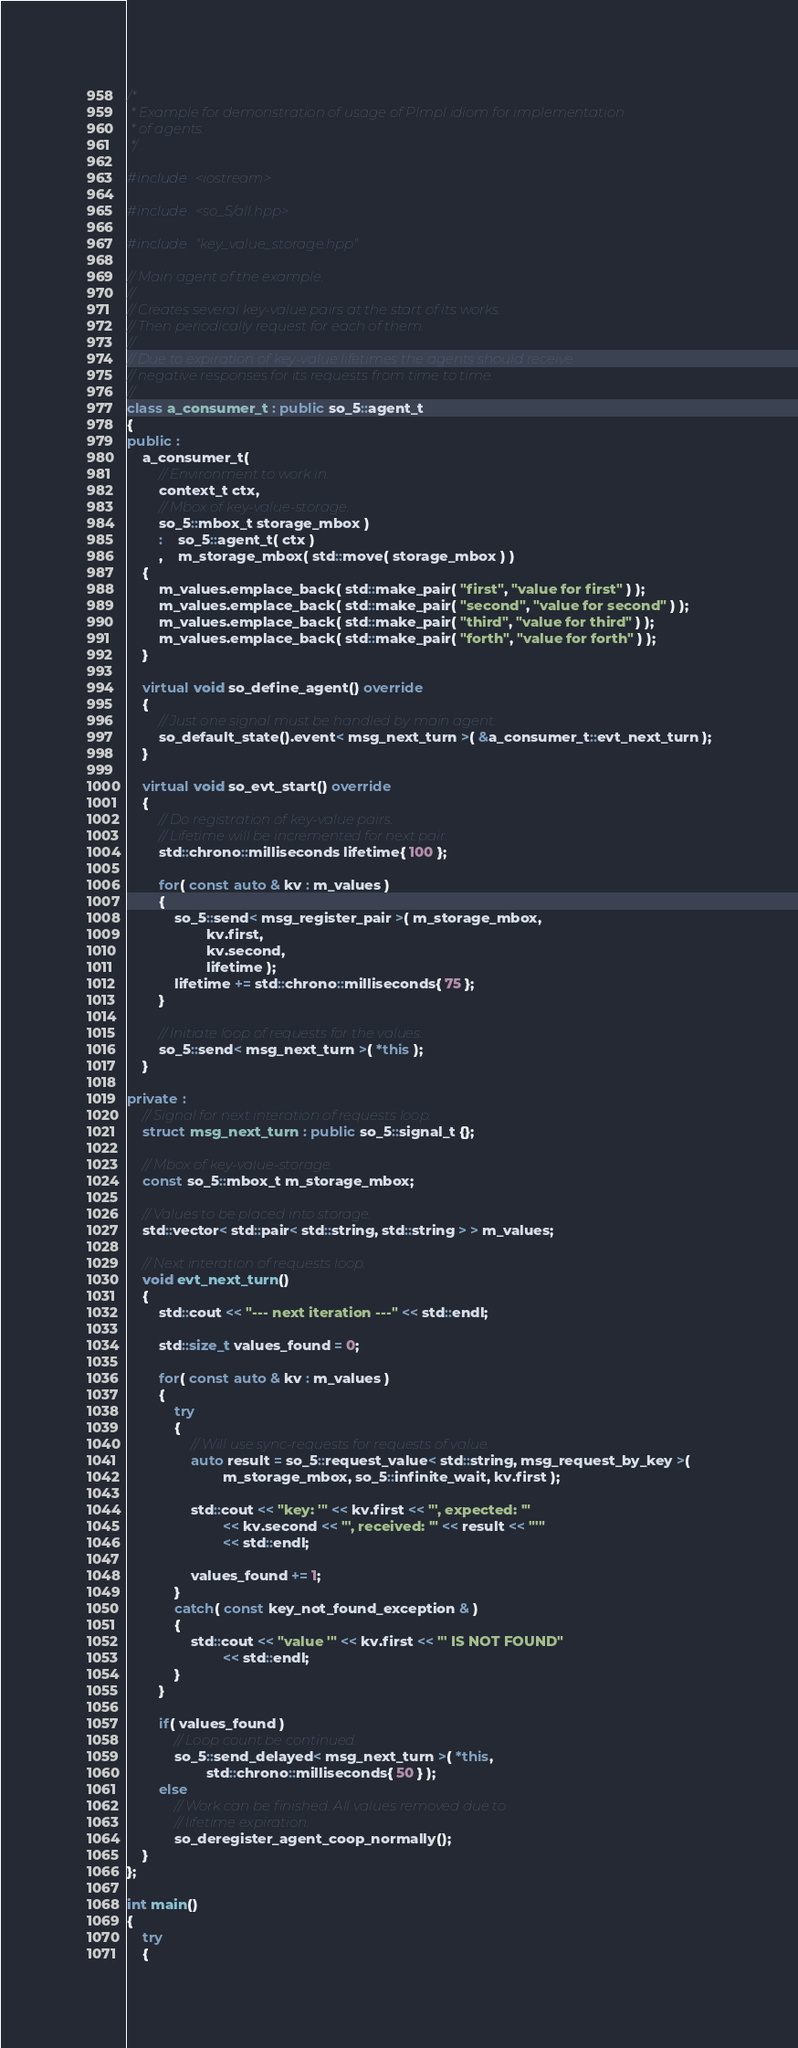Convert code to text. <code><loc_0><loc_0><loc_500><loc_500><_C++_>/*
 * Example for demonstration of usage of PImpl idiom for implementation
 * of agents.
 */

#include <iostream>

#include <so_5/all.hpp>

#include "key_value_storage.hpp"

// Main agent of the example.
//
// Creates several key-value pairs at the start of its works.
// Then periodically request for each of them.
//
// Due to expiration of key-value lifetimes the agents should receive
// negative responses for its requests from time to time.
//
class a_consumer_t : public so_5::agent_t
{
public :
	a_consumer_t(
		// Environment to work in.
		context_t ctx,
		// Mbox of key-value-storage.
		so_5::mbox_t storage_mbox )
		:	so_5::agent_t( ctx )
		,	m_storage_mbox( std::move( storage_mbox ) )
	{
		m_values.emplace_back( std::make_pair( "first", "value for first" ) );
		m_values.emplace_back( std::make_pair( "second", "value for second" ) );
		m_values.emplace_back( std::make_pair( "third", "value for third" ) );
		m_values.emplace_back( std::make_pair( "forth", "value for forth" ) );
	}

	virtual void so_define_agent() override
	{
		// Just one signal must be handled by main agent.
		so_default_state().event< msg_next_turn >( &a_consumer_t::evt_next_turn );
	}

	virtual void so_evt_start() override
	{
		// Do registration of key-value pairs.
		// Lifetime will be incremented for next pair.
		std::chrono::milliseconds lifetime{ 100 };

		for( const auto & kv : m_values )
		{
			so_5::send< msg_register_pair >( m_storage_mbox,
					kv.first,
					kv.second,
					lifetime );
			lifetime += std::chrono::milliseconds{ 75 }; 
		}

		// Initiate loop of requests for the values.
		so_5::send< msg_next_turn >( *this );
	}

private :
	// Signal for next interation of requests loop.
	struct msg_next_turn : public so_5::signal_t {};

	// Mbox of key-value-storage.
	const so_5::mbox_t m_storage_mbox;

	// Values to be placed into storage.
	std::vector< std::pair< std::string, std::string > > m_values;

	// Next interation of requests loop.
	void evt_next_turn()
	{
		std::cout << "--- next iteration ---" << std::endl;

		std::size_t values_found = 0;

		for( const auto & kv : m_values )
		{
			try
			{
				// Will use sync-requests for requests of value.
				auto result = so_5::request_value< std::string, msg_request_by_key >(
						m_storage_mbox, so_5::infinite_wait, kv.first );

				std::cout << "key: '" << kv.first << "', expected: '"
						<< kv.second << "', received: '" << result << "'"
						<< std::endl;

				values_found += 1;
			}
			catch( const key_not_found_exception & )
			{
				std::cout << "value '" << kv.first << "' IS NOT FOUND"
						<< std::endl;
			}
		}

		if( values_found )
			// Loop count be continued.
			so_5::send_delayed< msg_next_turn >( *this,
					std::chrono::milliseconds{ 50 } );
		else
			// Work can be finished. All values removed due to
			// lifetime expiration.
			so_deregister_agent_coop_normally();
	}
};

int main()
{
	try
	{</code> 